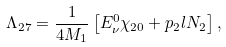Convert formula to latex. <formula><loc_0><loc_0><loc_500><loc_500>\Lambda _ { 2 7 } = \frac { 1 } { 4 M _ { 1 } } \left [ E _ { \nu } ^ { 0 } \chi _ { 2 0 } + p _ { 2 } l N _ { 2 } \right ] ,</formula> 